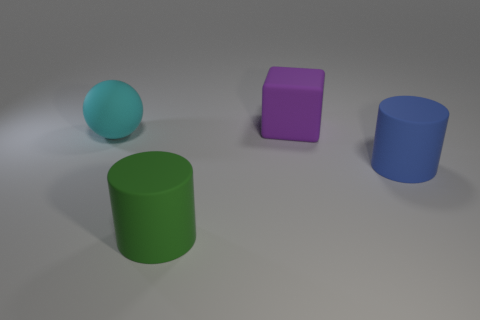Subtract all blocks. How many objects are left? 3 Add 1 small blue balls. How many objects exist? 5 Subtract 1 cylinders. How many cylinders are left? 1 Subtract all big blue things. Subtract all tiny gray metallic things. How many objects are left? 3 Add 3 large cyan matte things. How many large cyan matte things are left? 4 Add 4 matte balls. How many matte balls exist? 5 Subtract 1 cyan spheres. How many objects are left? 3 Subtract all brown cylinders. Subtract all brown blocks. How many cylinders are left? 2 Subtract all purple balls. How many gray cubes are left? 0 